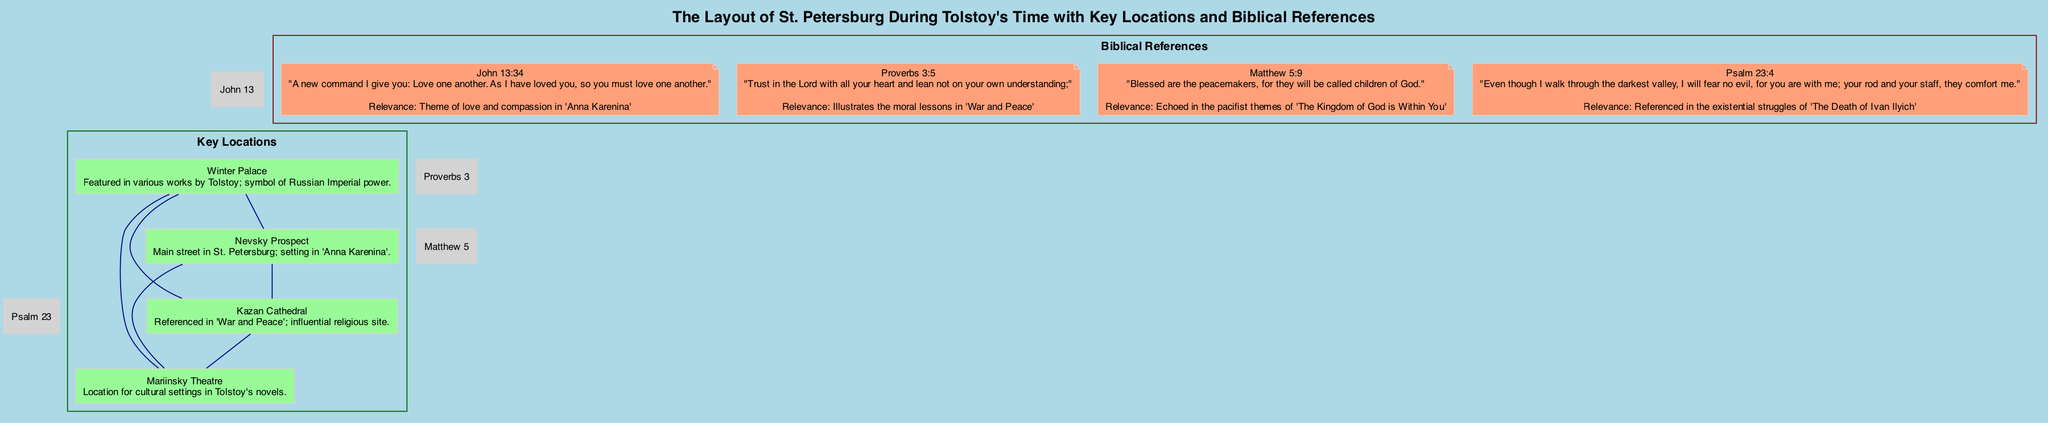What is the main street featured in "Anna Karenina"? The diagram explicitly labels "Nevsky Prospect" as the main street in St. Petersburg and states that it is a setting in "Anna Karenina."
Answer: Nevsky Prospect How many biblical references are included in the diagram? The diagram lists four biblical references under the "Biblical References" section, each with a description.
Answer: 4 Which location symbolizes Russian Imperial power? The diagram notes that the "Winter Palace" is featured in various works by Tolstoy and symbolizes Russian Imperial power.
Answer: Winter Palace What location is referenced in "War and Peace"? The diagram specifically mentions "Kazan Cathedral" under the locations, highlighting its reference in "War and Peace."
Answer: Kazan Cathedral Which biblical quote is connected to the theme of love in "Anna Karenina"? The diagram lists "John 13:34," which is associated with the theme of love and compassion in "Anna Karenina."
Answer: John 13:34 How many edges are there connecting the locations? The diagram's edge connections indicate that there are six edges connecting the four locations (as each location connects with every other location once).
Answer: 6 Which location is associated with cultural settings in Tolstoy's novels? The diagram describes "Mariinsky Theatre" as a location for cultural settings in Tolstoy's works.
Answer: Mariinsky Theatre Which biblical reference echoes the pacifist themes of Tolstoy’s work? The diagram associates "Matthew 5:9" with the pacifist themes in "The Kingdom of God is Within You."
Answer: Matthew 5:9 What is the latitude of Kazan Cathedral? The diagram provides the coordinates for Kazan Cathedral, with its latitude noted as 59.9340.
Answer: 59.9340 